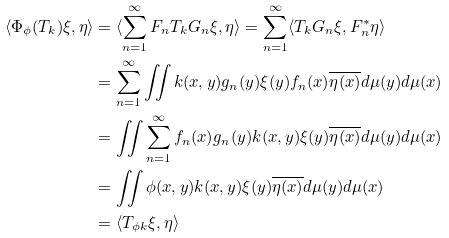Convert formula to latex. <formula><loc_0><loc_0><loc_500><loc_500>\langle \Phi _ { \phi } ( T _ { k } ) \xi , \eta \rangle & = \langle \sum _ { n = 1 } ^ { \infty } F _ { n } T _ { k } G _ { n } \xi , \eta \rangle = \sum _ { n = 1 } ^ { \infty } \langle T _ { k } G _ { n } \xi , F _ { n } ^ { \ast } \eta \rangle \\ & = \sum _ { n = 1 } ^ { \infty } \iint k ( x , y ) g _ { n } ( y ) \xi ( y ) f _ { n } ( x ) \overline { \eta ( x ) } d \mu ( y ) d \mu ( x ) \\ & = \iint \sum _ { n = 1 } ^ { \infty } f _ { n } ( x ) g _ { n } ( y ) k ( x , y ) \xi ( y ) \overline { \eta ( x ) } d \mu ( y ) d \mu ( x ) \\ & = \iint \phi ( x , y ) k ( x , y ) \xi ( y ) \overline { \eta ( x ) } d \mu ( y ) d \mu ( x ) \\ & = \langle T _ { \phi k } \xi , \eta \rangle</formula> 